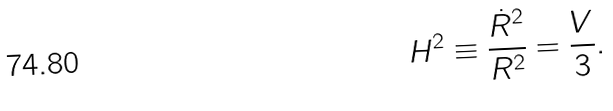<formula> <loc_0><loc_0><loc_500><loc_500>H ^ { 2 } \equiv \frac { \dot { R } ^ { 2 } } { R ^ { 2 } } = \frac { V } { 3 } .</formula> 